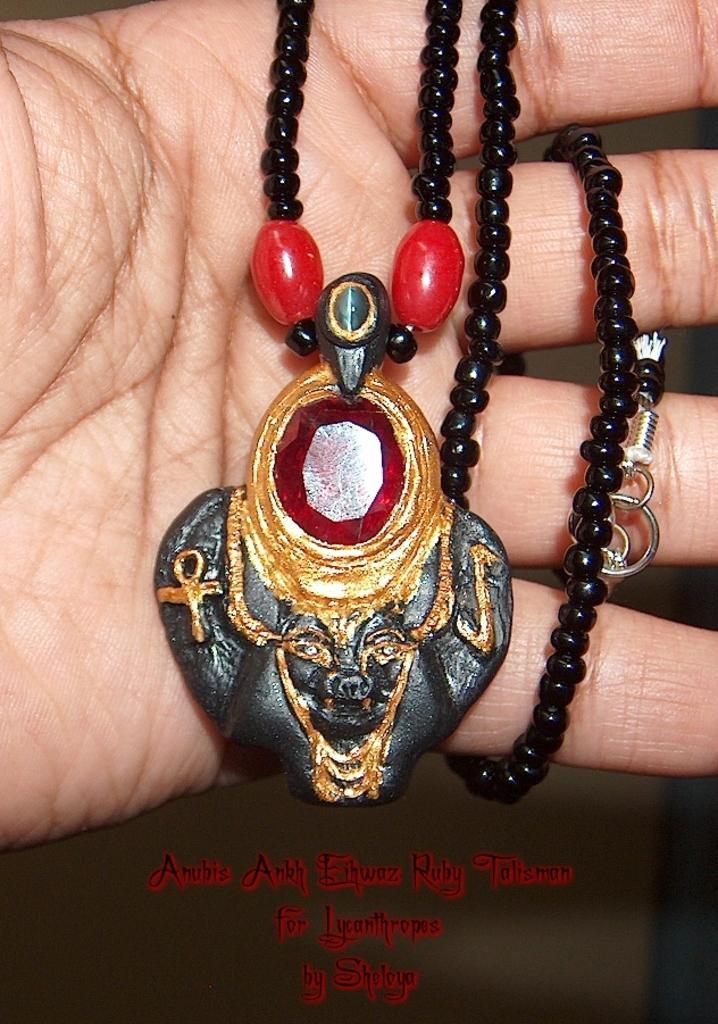Please provide a concise description of this image. In this picture we can see a person hand and chain with locket. 